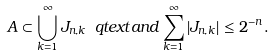<formula> <loc_0><loc_0><loc_500><loc_500>A \subset \bigcup _ { k = 1 } ^ { \infty } J _ { n , k } \ q t e x t { a n d } \sum _ { k = 1 } ^ { \infty } | J _ { n , k } | \leq 2 ^ { - n } .</formula> 